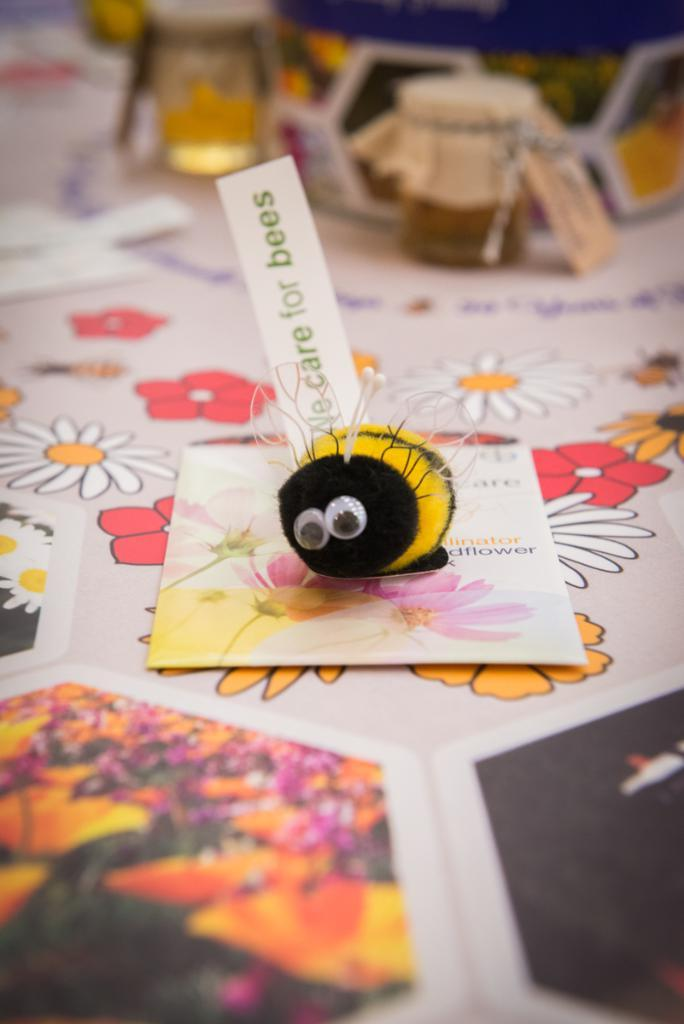Provide a one-sentence caption for the provided image. A STUFFED BEE LAYING ON TOP OF A GREETING CARD THAT READS CARE FOR BEES. 